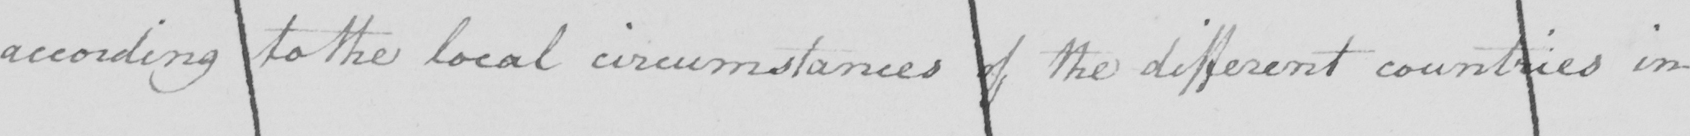Transcribe the text shown in this historical manuscript line. according to the local circumstances of the different countries in 